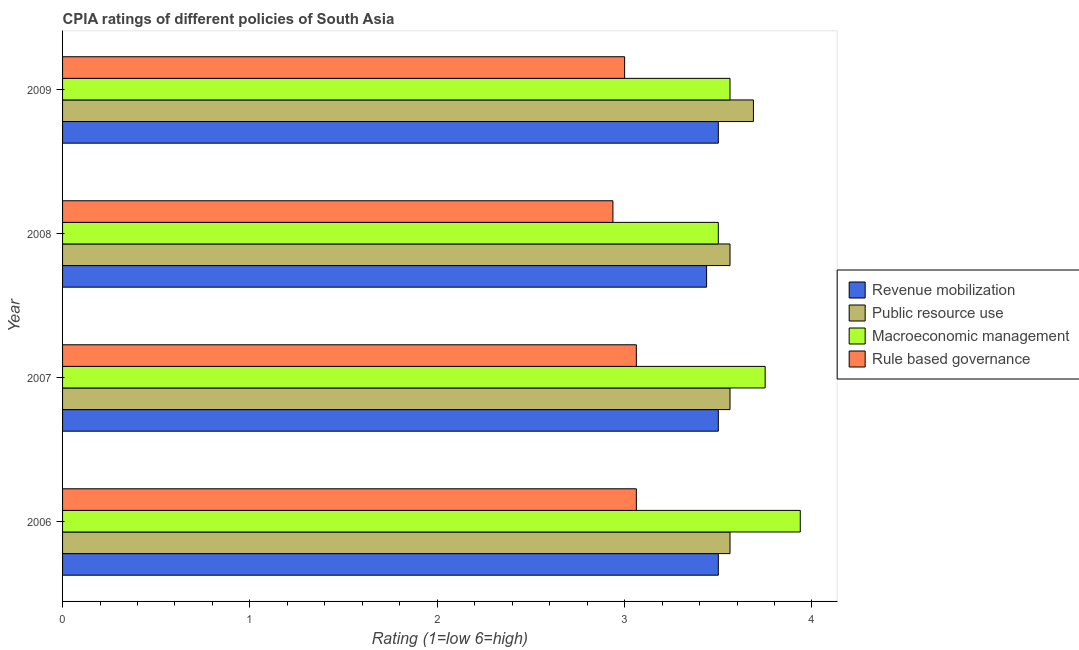How many different coloured bars are there?
Make the answer very short. 4. How many groups of bars are there?
Provide a succinct answer. 4. How many bars are there on the 3rd tick from the bottom?
Your answer should be compact. 4. What is the label of the 2nd group of bars from the top?
Your response must be concise. 2008. What is the cpia rating of revenue mobilization in 2008?
Give a very brief answer. 3.44. Across all years, what is the maximum cpia rating of rule based governance?
Ensure brevity in your answer.  3.06. Across all years, what is the minimum cpia rating of rule based governance?
Keep it short and to the point. 2.94. In which year was the cpia rating of macroeconomic management maximum?
Keep it short and to the point. 2006. In which year was the cpia rating of macroeconomic management minimum?
Your answer should be very brief. 2008. What is the total cpia rating of revenue mobilization in the graph?
Ensure brevity in your answer.  13.94. What is the difference between the cpia rating of macroeconomic management in 2006 and that in 2007?
Provide a succinct answer. 0.19. What is the average cpia rating of rule based governance per year?
Provide a succinct answer. 3.02. In the year 2008, what is the difference between the cpia rating of revenue mobilization and cpia rating of public resource use?
Ensure brevity in your answer.  -0.12. Is the difference between the cpia rating of macroeconomic management in 2007 and 2008 greater than the difference between the cpia rating of public resource use in 2007 and 2008?
Ensure brevity in your answer.  Yes. What is the difference between the highest and the second highest cpia rating of revenue mobilization?
Keep it short and to the point. 0. In how many years, is the cpia rating of rule based governance greater than the average cpia rating of rule based governance taken over all years?
Provide a short and direct response. 2. Is it the case that in every year, the sum of the cpia rating of public resource use and cpia rating of macroeconomic management is greater than the sum of cpia rating of rule based governance and cpia rating of revenue mobilization?
Offer a very short reply. No. What does the 1st bar from the top in 2006 represents?
Make the answer very short. Rule based governance. What does the 4th bar from the bottom in 2008 represents?
Offer a very short reply. Rule based governance. How many years are there in the graph?
Make the answer very short. 4. What is the difference between two consecutive major ticks on the X-axis?
Offer a very short reply. 1. Are the values on the major ticks of X-axis written in scientific E-notation?
Make the answer very short. No. Where does the legend appear in the graph?
Your answer should be very brief. Center right. How many legend labels are there?
Make the answer very short. 4. What is the title of the graph?
Provide a short and direct response. CPIA ratings of different policies of South Asia. Does "Tertiary schools" appear as one of the legend labels in the graph?
Ensure brevity in your answer.  No. What is the Rating (1=low 6=high) in Revenue mobilization in 2006?
Keep it short and to the point. 3.5. What is the Rating (1=low 6=high) of Public resource use in 2006?
Keep it short and to the point. 3.56. What is the Rating (1=low 6=high) of Macroeconomic management in 2006?
Offer a terse response. 3.94. What is the Rating (1=low 6=high) of Rule based governance in 2006?
Offer a terse response. 3.06. What is the Rating (1=low 6=high) in Public resource use in 2007?
Offer a very short reply. 3.56. What is the Rating (1=low 6=high) in Macroeconomic management in 2007?
Give a very brief answer. 3.75. What is the Rating (1=low 6=high) in Rule based governance in 2007?
Provide a succinct answer. 3.06. What is the Rating (1=low 6=high) in Revenue mobilization in 2008?
Give a very brief answer. 3.44. What is the Rating (1=low 6=high) in Public resource use in 2008?
Offer a very short reply. 3.56. What is the Rating (1=low 6=high) of Macroeconomic management in 2008?
Provide a short and direct response. 3.5. What is the Rating (1=low 6=high) of Rule based governance in 2008?
Make the answer very short. 2.94. What is the Rating (1=low 6=high) in Revenue mobilization in 2009?
Provide a short and direct response. 3.5. What is the Rating (1=low 6=high) in Public resource use in 2009?
Make the answer very short. 3.69. What is the Rating (1=low 6=high) in Macroeconomic management in 2009?
Your response must be concise. 3.56. What is the Rating (1=low 6=high) in Rule based governance in 2009?
Your answer should be compact. 3. Across all years, what is the maximum Rating (1=low 6=high) of Revenue mobilization?
Ensure brevity in your answer.  3.5. Across all years, what is the maximum Rating (1=low 6=high) of Public resource use?
Offer a terse response. 3.69. Across all years, what is the maximum Rating (1=low 6=high) of Macroeconomic management?
Offer a terse response. 3.94. Across all years, what is the maximum Rating (1=low 6=high) of Rule based governance?
Provide a succinct answer. 3.06. Across all years, what is the minimum Rating (1=low 6=high) in Revenue mobilization?
Offer a terse response. 3.44. Across all years, what is the minimum Rating (1=low 6=high) in Public resource use?
Keep it short and to the point. 3.56. Across all years, what is the minimum Rating (1=low 6=high) in Rule based governance?
Make the answer very short. 2.94. What is the total Rating (1=low 6=high) of Revenue mobilization in the graph?
Offer a very short reply. 13.94. What is the total Rating (1=low 6=high) of Public resource use in the graph?
Make the answer very short. 14.38. What is the total Rating (1=low 6=high) in Macroeconomic management in the graph?
Make the answer very short. 14.75. What is the total Rating (1=low 6=high) of Rule based governance in the graph?
Your response must be concise. 12.06. What is the difference between the Rating (1=low 6=high) of Macroeconomic management in 2006 and that in 2007?
Your answer should be compact. 0.19. What is the difference between the Rating (1=low 6=high) of Revenue mobilization in 2006 and that in 2008?
Make the answer very short. 0.06. What is the difference between the Rating (1=low 6=high) of Macroeconomic management in 2006 and that in 2008?
Your response must be concise. 0.44. What is the difference between the Rating (1=low 6=high) in Rule based governance in 2006 and that in 2008?
Your answer should be compact. 0.12. What is the difference between the Rating (1=low 6=high) in Revenue mobilization in 2006 and that in 2009?
Make the answer very short. 0. What is the difference between the Rating (1=low 6=high) in Public resource use in 2006 and that in 2009?
Offer a very short reply. -0.12. What is the difference between the Rating (1=low 6=high) in Rule based governance in 2006 and that in 2009?
Provide a succinct answer. 0.06. What is the difference between the Rating (1=low 6=high) in Revenue mobilization in 2007 and that in 2008?
Your response must be concise. 0.06. What is the difference between the Rating (1=low 6=high) of Public resource use in 2007 and that in 2008?
Offer a very short reply. 0. What is the difference between the Rating (1=low 6=high) in Macroeconomic management in 2007 and that in 2008?
Provide a short and direct response. 0.25. What is the difference between the Rating (1=low 6=high) in Public resource use in 2007 and that in 2009?
Make the answer very short. -0.12. What is the difference between the Rating (1=low 6=high) of Macroeconomic management in 2007 and that in 2009?
Your answer should be very brief. 0.19. What is the difference between the Rating (1=low 6=high) of Rule based governance in 2007 and that in 2009?
Your response must be concise. 0.06. What is the difference between the Rating (1=low 6=high) of Revenue mobilization in 2008 and that in 2009?
Provide a short and direct response. -0.06. What is the difference between the Rating (1=low 6=high) of Public resource use in 2008 and that in 2009?
Offer a terse response. -0.12. What is the difference between the Rating (1=low 6=high) in Macroeconomic management in 2008 and that in 2009?
Your answer should be very brief. -0.06. What is the difference between the Rating (1=low 6=high) of Rule based governance in 2008 and that in 2009?
Provide a short and direct response. -0.06. What is the difference between the Rating (1=low 6=high) of Revenue mobilization in 2006 and the Rating (1=low 6=high) of Public resource use in 2007?
Your answer should be compact. -0.06. What is the difference between the Rating (1=low 6=high) in Revenue mobilization in 2006 and the Rating (1=low 6=high) in Rule based governance in 2007?
Provide a short and direct response. 0.44. What is the difference between the Rating (1=low 6=high) in Public resource use in 2006 and the Rating (1=low 6=high) in Macroeconomic management in 2007?
Offer a terse response. -0.19. What is the difference between the Rating (1=low 6=high) of Public resource use in 2006 and the Rating (1=low 6=high) of Rule based governance in 2007?
Your response must be concise. 0.5. What is the difference between the Rating (1=low 6=high) of Macroeconomic management in 2006 and the Rating (1=low 6=high) of Rule based governance in 2007?
Ensure brevity in your answer.  0.88. What is the difference between the Rating (1=low 6=high) of Revenue mobilization in 2006 and the Rating (1=low 6=high) of Public resource use in 2008?
Your answer should be very brief. -0.06. What is the difference between the Rating (1=low 6=high) of Revenue mobilization in 2006 and the Rating (1=low 6=high) of Rule based governance in 2008?
Provide a succinct answer. 0.56. What is the difference between the Rating (1=low 6=high) in Public resource use in 2006 and the Rating (1=low 6=high) in Macroeconomic management in 2008?
Provide a short and direct response. 0.06. What is the difference between the Rating (1=low 6=high) in Macroeconomic management in 2006 and the Rating (1=low 6=high) in Rule based governance in 2008?
Offer a very short reply. 1. What is the difference between the Rating (1=low 6=high) in Revenue mobilization in 2006 and the Rating (1=low 6=high) in Public resource use in 2009?
Your answer should be very brief. -0.19. What is the difference between the Rating (1=low 6=high) of Revenue mobilization in 2006 and the Rating (1=low 6=high) of Macroeconomic management in 2009?
Your response must be concise. -0.06. What is the difference between the Rating (1=low 6=high) of Revenue mobilization in 2006 and the Rating (1=low 6=high) of Rule based governance in 2009?
Your response must be concise. 0.5. What is the difference between the Rating (1=low 6=high) in Public resource use in 2006 and the Rating (1=low 6=high) in Macroeconomic management in 2009?
Give a very brief answer. 0. What is the difference between the Rating (1=low 6=high) of Public resource use in 2006 and the Rating (1=low 6=high) of Rule based governance in 2009?
Your answer should be very brief. 0.56. What is the difference between the Rating (1=low 6=high) in Revenue mobilization in 2007 and the Rating (1=low 6=high) in Public resource use in 2008?
Your response must be concise. -0.06. What is the difference between the Rating (1=low 6=high) of Revenue mobilization in 2007 and the Rating (1=low 6=high) of Macroeconomic management in 2008?
Provide a short and direct response. 0. What is the difference between the Rating (1=low 6=high) of Revenue mobilization in 2007 and the Rating (1=low 6=high) of Rule based governance in 2008?
Give a very brief answer. 0.56. What is the difference between the Rating (1=low 6=high) of Public resource use in 2007 and the Rating (1=low 6=high) of Macroeconomic management in 2008?
Provide a succinct answer. 0.06. What is the difference between the Rating (1=low 6=high) of Macroeconomic management in 2007 and the Rating (1=low 6=high) of Rule based governance in 2008?
Offer a very short reply. 0.81. What is the difference between the Rating (1=low 6=high) of Revenue mobilization in 2007 and the Rating (1=low 6=high) of Public resource use in 2009?
Offer a very short reply. -0.19. What is the difference between the Rating (1=low 6=high) in Revenue mobilization in 2007 and the Rating (1=low 6=high) in Macroeconomic management in 2009?
Offer a terse response. -0.06. What is the difference between the Rating (1=low 6=high) in Public resource use in 2007 and the Rating (1=low 6=high) in Macroeconomic management in 2009?
Ensure brevity in your answer.  0. What is the difference between the Rating (1=low 6=high) of Public resource use in 2007 and the Rating (1=low 6=high) of Rule based governance in 2009?
Provide a succinct answer. 0.56. What is the difference between the Rating (1=low 6=high) of Macroeconomic management in 2007 and the Rating (1=low 6=high) of Rule based governance in 2009?
Provide a succinct answer. 0.75. What is the difference between the Rating (1=low 6=high) in Revenue mobilization in 2008 and the Rating (1=low 6=high) in Public resource use in 2009?
Offer a very short reply. -0.25. What is the difference between the Rating (1=low 6=high) of Revenue mobilization in 2008 and the Rating (1=low 6=high) of Macroeconomic management in 2009?
Give a very brief answer. -0.12. What is the difference between the Rating (1=low 6=high) in Revenue mobilization in 2008 and the Rating (1=low 6=high) in Rule based governance in 2009?
Your answer should be very brief. 0.44. What is the difference between the Rating (1=low 6=high) in Public resource use in 2008 and the Rating (1=low 6=high) in Rule based governance in 2009?
Give a very brief answer. 0.56. What is the difference between the Rating (1=low 6=high) of Macroeconomic management in 2008 and the Rating (1=low 6=high) of Rule based governance in 2009?
Keep it short and to the point. 0.5. What is the average Rating (1=low 6=high) of Revenue mobilization per year?
Give a very brief answer. 3.48. What is the average Rating (1=low 6=high) of Public resource use per year?
Give a very brief answer. 3.59. What is the average Rating (1=low 6=high) of Macroeconomic management per year?
Make the answer very short. 3.69. What is the average Rating (1=low 6=high) in Rule based governance per year?
Provide a short and direct response. 3.02. In the year 2006, what is the difference between the Rating (1=low 6=high) of Revenue mobilization and Rating (1=low 6=high) of Public resource use?
Your answer should be compact. -0.06. In the year 2006, what is the difference between the Rating (1=low 6=high) in Revenue mobilization and Rating (1=low 6=high) in Macroeconomic management?
Make the answer very short. -0.44. In the year 2006, what is the difference between the Rating (1=low 6=high) of Revenue mobilization and Rating (1=low 6=high) of Rule based governance?
Make the answer very short. 0.44. In the year 2006, what is the difference between the Rating (1=low 6=high) in Public resource use and Rating (1=low 6=high) in Macroeconomic management?
Provide a succinct answer. -0.38. In the year 2007, what is the difference between the Rating (1=low 6=high) in Revenue mobilization and Rating (1=low 6=high) in Public resource use?
Your answer should be very brief. -0.06. In the year 2007, what is the difference between the Rating (1=low 6=high) of Revenue mobilization and Rating (1=low 6=high) of Macroeconomic management?
Keep it short and to the point. -0.25. In the year 2007, what is the difference between the Rating (1=low 6=high) of Revenue mobilization and Rating (1=low 6=high) of Rule based governance?
Give a very brief answer. 0.44. In the year 2007, what is the difference between the Rating (1=low 6=high) in Public resource use and Rating (1=low 6=high) in Macroeconomic management?
Make the answer very short. -0.19. In the year 2007, what is the difference between the Rating (1=low 6=high) in Public resource use and Rating (1=low 6=high) in Rule based governance?
Your answer should be compact. 0.5. In the year 2007, what is the difference between the Rating (1=low 6=high) in Macroeconomic management and Rating (1=low 6=high) in Rule based governance?
Your answer should be very brief. 0.69. In the year 2008, what is the difference between the Rating (1=low 6=high) in Revenue mobilization and Rating (1=low 6=high) in Public resource use?
Your answer should be very brief. -0.12. In the year 2008, what is the difference between the Rating (1=low 6=high) of Revenue mobilization and Rating (1=low 6=high) of Macroeconomic management?
Make the answer very short. -0.06. In the year 2008, what is the difference between the Rating (1=low 6=high) in Public resource use and Rating (1=low 6=high) in Macroeconomic management?
Offer a very short reply. 0.06. In the year 2008, what is the difference between the Rating (1=low 6=high) of Public resource use and Rating (1=low 6=high) of Rule based governance?
Offer a terse response. 0.62. In the year 2008, what is the difference between the Rating (1=low 6=high) in Macroeconomic management and Rating (1=low 6=high) in Rule based governance?
Offer a terse response. 0.56. In the year 2009, what is the difference between the Rating (1=low 6=high) in Revenue mobilization and Rating (1=low 6=high) in Public resource use?
Your answer should be compact. -0.19. In the year 2009, what is the difference between the Rating (1=low 6=high) of Revenue mobilization and Rating (1=low 6=high) of Macroeconomic management?
Provide a succinct answer. -0.06. In the year 2009, what is the difference between the Rating (1=low 6=high) of Public resource use and Rating (1=low 6=high) of Macroeconomic management?
Offer a very short reply. 0.12. In the year 2009, what is the difference between the Rating (1=low 6=high) of Public resource use and Rating (1=low 6=high) of Rule based governance?
Give a very brief answer. 0.69. In the year 2009, what is the difference between the Rating (1=low 6=high) of Macroeconomic management and Rating (1=low 6=high) of Rule based governance?
Give a very brief answer. 0.56. What is the ratio of the Rating (1=low 6=high) of Revenue mobilization in 2006 to that in 2007?
Your response must be concise. 1. What is the ratio of the Rating (1=low 6=high) in Public resource use in 2006 to that in 2007?
Keep it short and to the point. 1. What is the ratio of the Rating (1=low 6=high) in Macroeconomic management in 2006 to that in 2007?
Keep it short and to the point. 1.05. What is the ratio of the Rating (1=low 6=high) of Rule based governance in 2006 to that in 2007?
Provide a succinct answer. 1. What is the ratio of the Rating (1=low 6=high) in Revenue mobilization in 2006 to that in 2008?
Your answer should be very brief. 1.02. What is the ratio of the Rating (1=low 6=high) in Macroeconomic management in 2006 to that in 2008?
Keep it short and to the point. 1.12. What is the ratio of the Rating (1=low 6=high) of Rule based governance in 2006 to that in 2008?
Keep it short and to the point. 1.04. What is the ratio of the Rating (1=low 6=high) of Revenue mobilization in 2006 to that in 2009?
Offer a very short reply. 1. What is the ratio of the Rating (1=low 6=high) of Public resource use in 2006 to that in 2009?
Provide a succinct answer. 0.97. What is the ratio of the Rating (1=low 6=high) of Macroeconomic management in 2006 to that in 2009?
Ensure brevity in your answer.  1.11. What is the ratio of the Rating (1=low 6=high) in Rule based governance in 2006 to that in 2009?
Your answer should be compact. 1.02. What is the ratio of the Rating (1=low 6=high) in Revenue mobilization in 2007 to that in 2008?
Give a very brief answer. 1.02. What is the ratio of the Rating (1=low 6=high) of Public resource use in 2007 to that in 2008?
Your answer should be very brief. 1. What is the ratio of the Rating (1=low 6=high) in Macroeconomic management in 2007 to that in 2008?
Give a very brief answer. 1.07. What is the ratio of the Rating (1=low 6=high) of Rule based governance in 2007 to that in 2008?
Your answer should be very brief. 1.04. What is the ratio of the Rating (1=low 6=high) of Revenue mobilization in 2007 to that in 2009?
Give a very brief answer. 1. What is the ratio of the Rating (1=low 6=high) in Public resource use in 2007 to that in 2009?
Your answer should be very brief. 0.97. What is the ratio of the Rating (1=low 6=high) in Macroeconomic management in 2007 to that in 2009?
Make the answer very short. 1.05. What is the ratio of the Rating (1=low 6=high) of Rule based governance in 2007 to that in 2009?
Keep it short and to the point. 1.02. What is the ratio of the Rating (1=low 6=high) in Revenue mobilization in 2008 to that in 2009?
Offer a terse response. 0.98. What is the ratio of the Rating (1=low 6=high) of Public resource use in 2008 to that in 2009?
Offer a very short reply. 0.97. What is the ratio of the Rating (1=low 6=high) of Macroeconomic management in 2008 to that in 2009?
Offer a terse response. 0.98. What is the ratio of the Rating (1=low 6=high) of Rule based governance in 2008 to that in 2009?
Make the answer very short. 0.98. What is the difference between the highest and the second highest Rating (1=low 6=high) in Public resource use?
Offer a terse response. 0.12. What is the difference between the highest and the second highest Rating (1=low 6=high) of Macroeconomic management?
Your response must be concise. 0.19. What is the difference between the highest and the lowest Rating (1=low 6=high) of Revenue mobilization?
Give a very brief answer. 0.06. What is the difference between the highest and the lowest Rating (1=low 6=high) of Public resource use?
Your response must be concise. 0.12. What is the difference between the highest and the lowest Rating (1=low 6=high) of Macroeconomic management?
Offer a terse response. 0.44. What is the difference between the highest and the lowest Rating (1=low 6=high) of Rule based governance?
Provide a short and direct response. 0.12. 